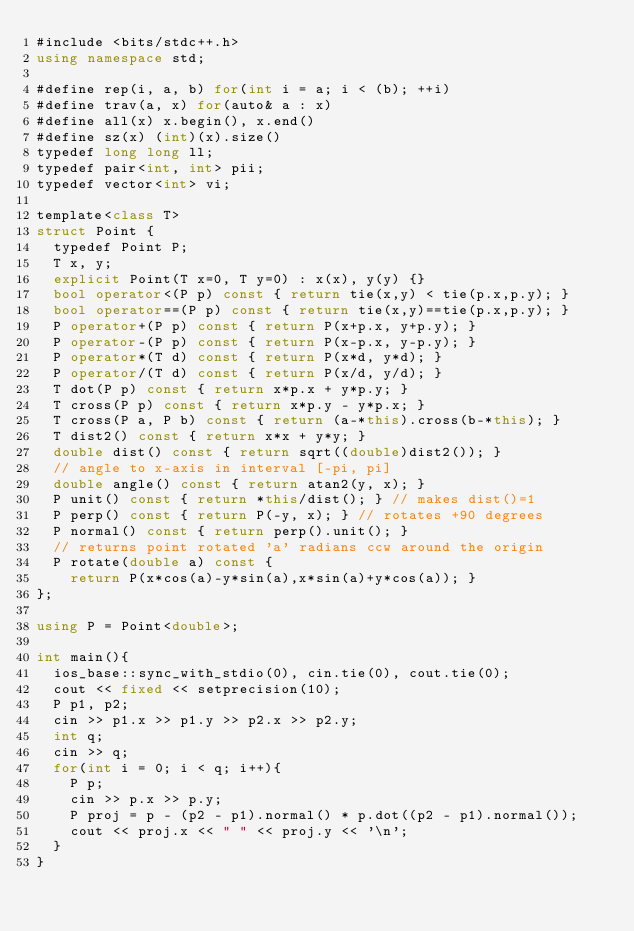<code> <loc_0><loc_0><loc_500><loc_500><_C#_>#include <bits/stdc++.h>
using namespace std;

#define rep(i, a, b) for(int i = a; i < (b); ++i)
#define trav(a, x) for(auto& a : x)
#define all(x) x.begin(), x.end()
#define sz(x) (int)(x).size()
typedef long long ll;
typedef pair<int, int> pii;
typedef vector<int> vi;

template<class T>
struct Point {
	typedef Point P;
	T x, y;
	explicit Point(T x=0, T y=0) : x(x), y(y) {}
	bool operator<(P p) const { return tie(x,y) < tie(p.x,p.y); }
	bool operator==(P p) const { return tie(x,y)==tie(p.x,p.y); }
	P operator+(P p) const { return P(x+p.x, y+p.y); }
	P operator-(P p) const { return P(x-p.x, y-p.y); }
	P operator*(T d) const { return P(x*d, y*d); }
	P operator/(T d) const { return P(x/d, y/d); }
	T dot(P p) const { return x*p.x + y*p.y; }
	T cross(P p) const { return x*p.y - y*p.x; }
	T cross(P a, P b) const { return (a-*this).cross(b-*this); }
	T dist2() const { return x*x + y*y; }
	double dist() const { return sqrt((double)dist2()); }
	// angle to x-axis in interval [-pi, pi]
	double angle() const { return atan2(y, x); }
	P unit() const { return *this/dist(); } // makes dist()=1
	P perp() const { return P(-y, x); } // rotates +90 degrees
	P normal() const { return perp().unit(); }
	// returns point rotated 'a' radians ccw around the origin
	P rotate(double a) const {
		return P(x*cos(a)-y*sin(a),x*sin(a)+y*cos(a)); }
};

using P = Point<double>;

int main(){
	ios_base::sync_with_stdio(0), cin.tie(0), cout.tie(0);
	cout << fixed << setprecision(10);
	P p1, p2;
	cin >> p1.x >> p1.y >> p2.x >> p2.y;
	int q;
	cin >> q;
	for(int i = 0; i < q; i++){
		P p;
		cin >> p.x >> p.y;
		P proj = p - (p2 - p1).normal() * p.dot((p2 - p1).normal());
		cout << proj.x << " " << proj.y << '\n';
	}
}
</code> 